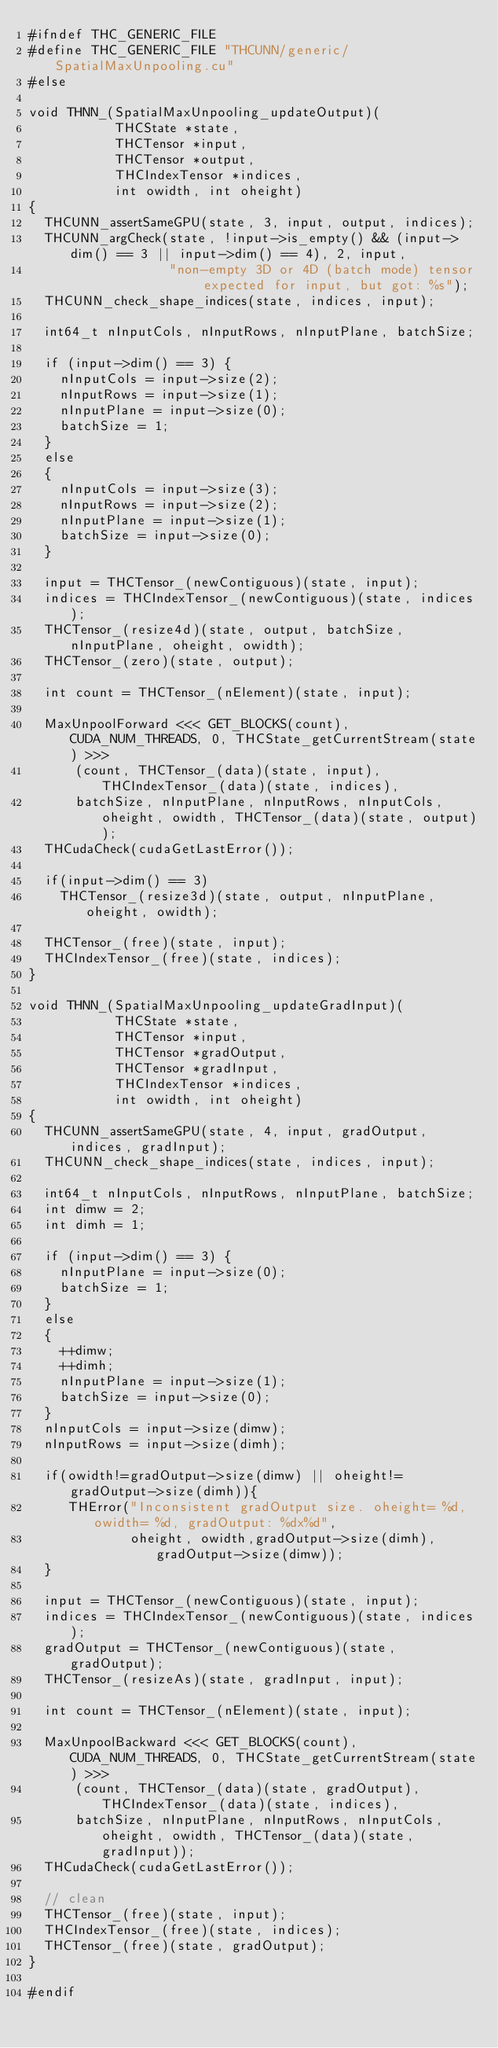Convert code to text. <code><loc_0><loc_0><loc_500><loc_500><_Cuda_>#ifndef THC_GENERIC_FILE
#define THC_GENERIC_FILE "THCUNN/generic/SpatialMaxUnpooling.cu"
#else

void THNN_(SpatialMaxUnpooling_updateOutput)(
           THCState *state,
           THCTensor *input,
           THCTensor *output,
           THCIndexTensor *indices,
           int owidth, int oheight)
{
  THCUNN_assertSameGPU(state, 3, input, output, indices);
  THCUNN_argCheck(state, !input->is_empty() && (input->dim() == 3 || input->dim() == 4), 2, input,
                  "non-empty 3D or 4D (batch mode) tensor expected for input, but got: %s");
  THCUNN_check_shape_indices(state, indices, input);

  int64_t nInputCols, nInputRows, nInputPlane, batchSize;

  if (input->dim() == 3) {
    nInputCols = input->size(2);
    nInputRows = input->size(1);
    nInputPlane = input->size(0);
    batchSize = 1;
  }
  else
  {
    nInputCols = input->size(3);
    nInputRows = input->size(2);
    nInputPlane = input->size(1);
    batchSize = input->size(0);
  }

  input = THCTensor_(newContiguous)(state, input);
  indices = THCIndexTensor_(newContiguous)(state, indices);
  THCTensor_(resize4d)(state, output, batchSize, nInputPlane, oheight, owidth);
  THCTensor_(zero)(state, output);

  int count = THCTensor_(nElement)(state, input);

  MaxUnpoolForward <<< GET_BLOCKS(count), CUDA_NUM_THREADS, 0, THCState_getCurrentStream(state) >>>
      (count, THCTensor_(data)(state, input), THCIndexTensor_(data)(state, indices),
      batchSize, nInputPlane, nInputRows, nInputCols, oheight, owidth, THCTensor_(data)(state, output));
  THCudaCheck(cudaGetLastError());

  if(input->dim() == 3)
    THCTensor_(resize3d)(state, output, nInputPlane, oheight, owidth);

  THCTensor_(free)(state, input);
  THCIndexTensor_(free)(state, indices);
}

void THNN_(SpatialMaxUnpooling_updateGradInput)(
           THCState *state,
           THCTensor *input,
           THCTensor *gradOutput,
           THCTensor *gradInput,
           THCIndexTensor *indices,
           int owidth, int oheight)
{
  THCUNN_assertSameGPU(state, 4, input, gradOutput, indices, gradInput);
  THCUNN_check_shape_indices(state, indices, input);

  int64_t nInputCols, nInputRows, nInputPlane, batchSize;
  int dimw = 2;
  int dimh = 1;

  if (input->dim() == 3) {
    nInputPlane = input->size(0);
    batchSize = 1;
  }
  else
  {
    ++dimw;
    ++dimh;
    nInputPlane = input->size(1);
    batchSize = input->size(0);
  }
  nInputCols = input->size(dimw);
  nInputRows = input->size(dimh);

  if(owidth!=gradOutput->size(dimw) || oheight!=gradOutput->size(dimh)){
     THError("Inconsistent gradOutput size. oheight= %d, owidth= %d, gradOutput: %dx%d",
             oheight, owidth,gradOutput->size(dimh),gradOutput->size(dimw));
  }

  input = THCTensor_(newContiguous)(state, input);
  indices = THCIndexTensor_(newContiguous)(state, indices);
  gradOutput = THCTensor_(newContiguous)(state, gradOutput);
  THCTensor_(resizeAs)(state, gradInput, input);

  int count = THCTensor_(nElement)(state, input);

  MaxUnpoolBackward <<< GET_BLOCKS(count), CUDA_NUM_THREADS, 0, THCState_getCurrentStream(state) >>>
      (count, THCTensor_(data)(state, gradOutput), THCIndexTensor_(data)(state, indices),
      batchSize, nInputPlane, nInputRows, nInputCols, oheight, owidth, THCTensor_(data)(state, gradInput));
  THCudaCheck(cudaGetLastError());

  // clean
  THCTensor_(free)(state, input);
  THCIndexTensor_(free)(state, indices);
  THCTensor_(free)(state, gradOutput);
}

#endif
</code> 